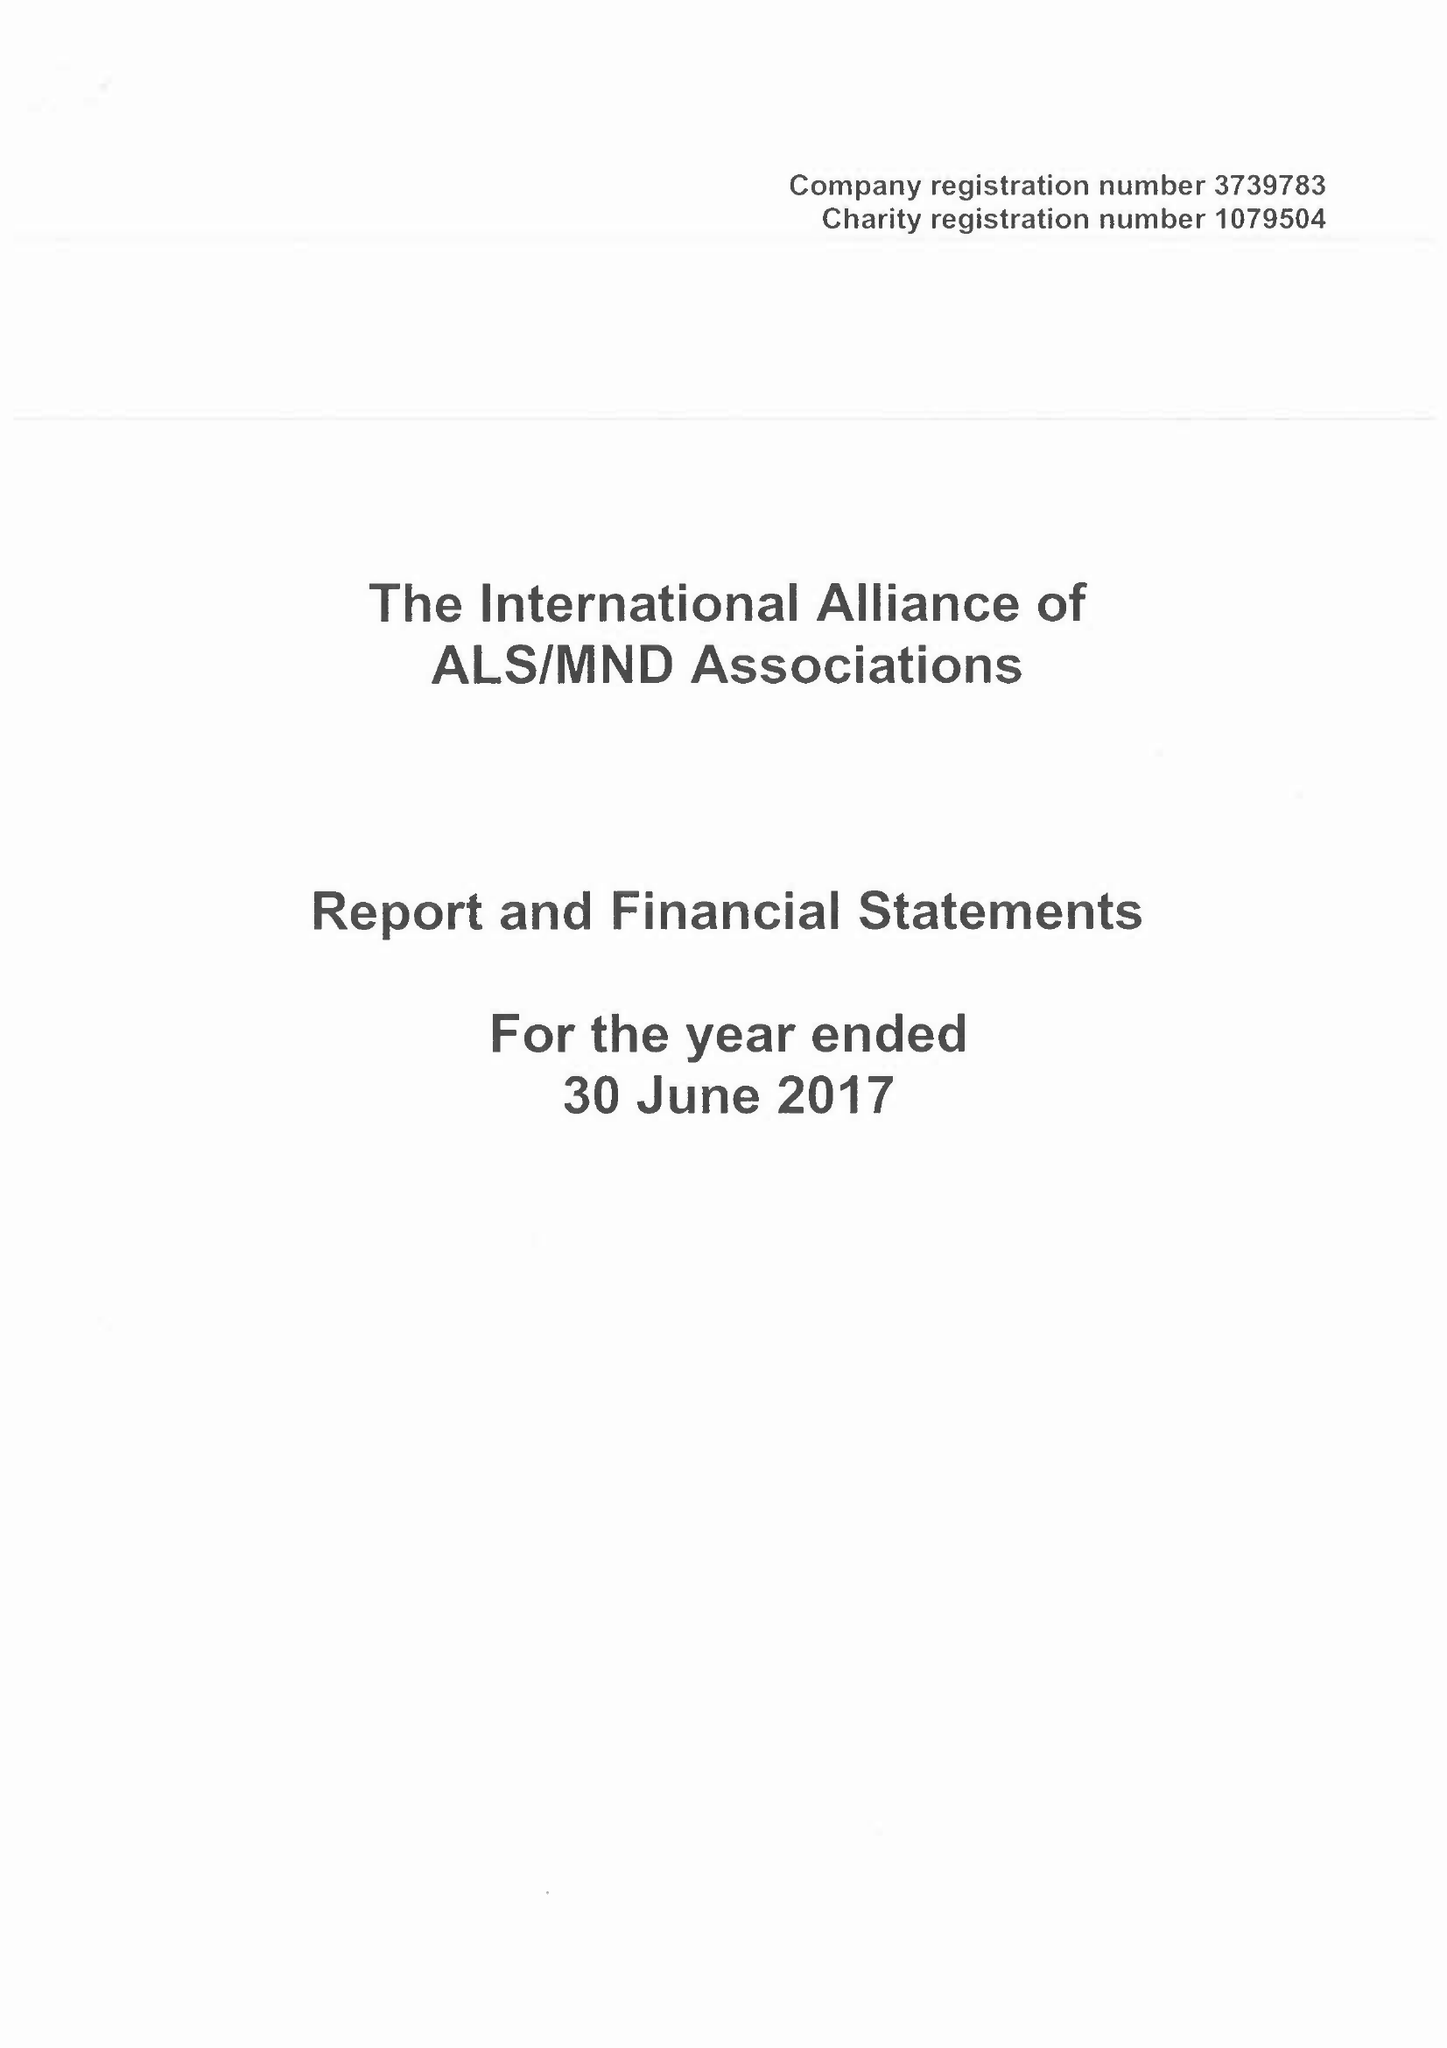What is the value for the address__street_line?
Answer the question using a single word or phrase. None 